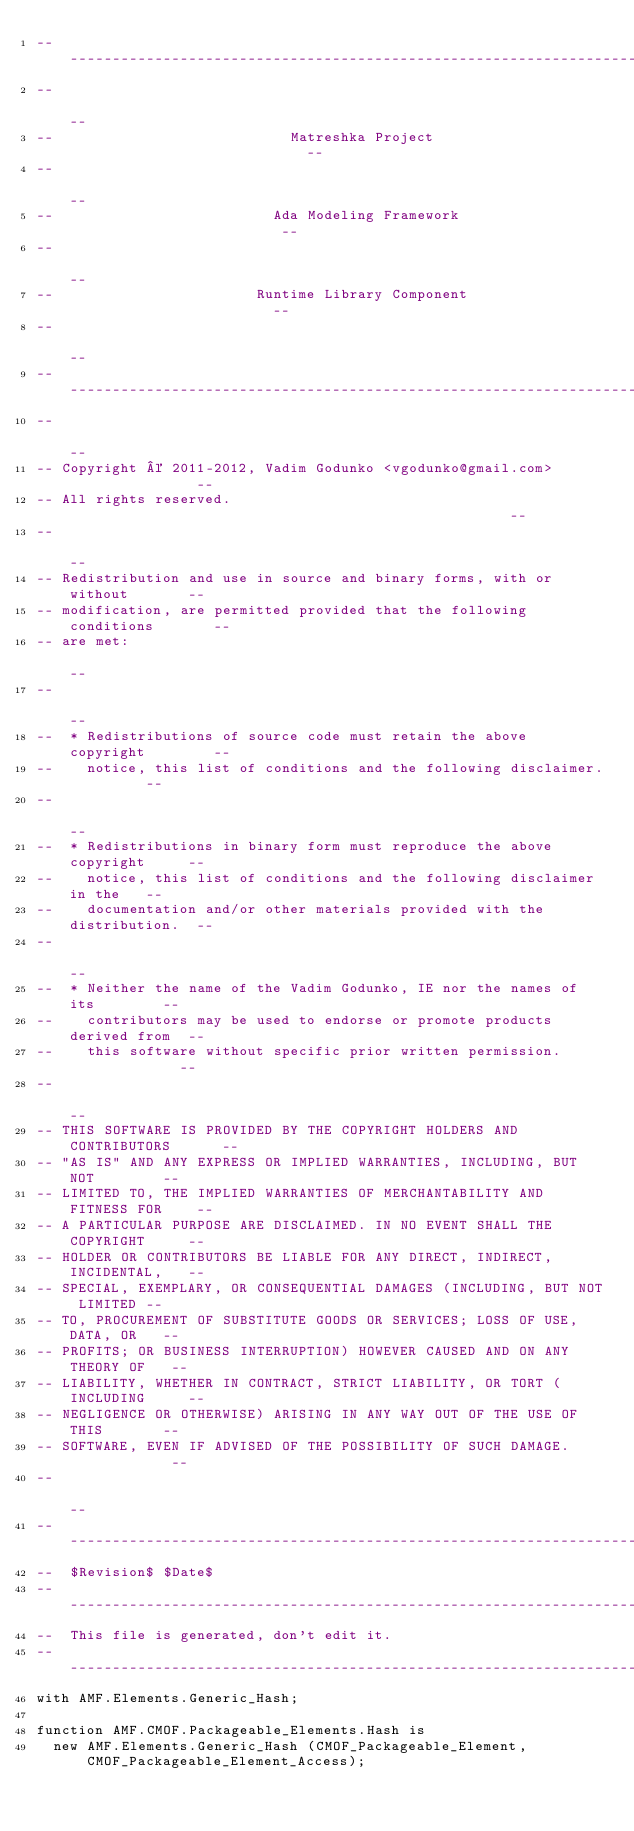<code> <loc_0><loc_0><loc_500><loc_500><_Ada_>------------------------------------------------------------------------------
--                                                                          --
--                            Matreshka Project                             --
--                                                                          --
--                          Ada Modeling Framework                          --
--                                                                          --
--                        Runtime Library Component                         --
--                                                                          --
------------------------------------------------------------------------------
--                                                                          --
-- Copyright © 2011-2012, Vadim Godunko <vgodunko@gmail.com>                --
-- All rights reserved.                                                     --
--                                                                          --
-- Redistribution and use in source and binary forms, with or without       --
-- modification, are permitted provided that the following conditions       --
-- are met:                                                                 --
--                                                                          --
--  * Redistributions of source code must retain the above copyright        --
--    notice, this list of conditions and the following disclaimer.         --
--                                                                          --
--  * Redistributions in binary form must reproduce the above copyright     --
--    notice, this list of conditions and the following disclaimer in the   --
--    documentation and/or other materials provided with the distribution.  --
--                                                                          --
--  * Neither the name of the Vadim Godunko, IE nor the names of its        --
--    contributors may be used to endorse or promote products derived from  --
--    this software without specific prior written permission.              --
--                                                                          --
-- THIS SOFTWARE IS PROVIDED BY THE COPYRIGHT HOLDERS AND CONTRIBUTORS      --
-- "AS IS" AND ANY EXPRESS OR IMPLIED WARRANTIES, INCLUDING, BUT NOT        --
-- LIMITED TO, THE IMPLIED WARRANTIES OF MERCHANTABILITY AND FITNESS FOR    --
-- A PARTICULAR PURPOSE ARE DISCLAIMED. IN NO EVENT SHALL THE COPYRIGHT     --
-- HOLDER OR CONTRIBUTORS BE LIABLE FOR ANY DIRECT, INDIRECT, INCIDENTAL,   --
-- SPECIAL, EXEMPLARY, OR CONSEQUENTIAL DAMAGES (INCLUDING, BUT NOT LIMITED --
-- TO, PROCUREMENT OF SUBSTITUTE GOODS OR SERVICES; LOSS OF USE, DATA, OR   --
-- PROFITS; OR BUSINESS INTERRUPTION) HOWEVER CAUSED AND ON ANY THEORY OF   --
-- LIABILITY, WHETHER IN CONTRACT, STRICT LIABILITY, OR TORT (INCLUDING     --
-- NEGLIGENCE OR OTHERWISE) ARISING IN ANY WAY OUT OF THE USE OF THIS       --
-- SOFTWARE, EVEN IF ADVISED OF THE POSSIBILITY OF SUCH DAMAGE.             --
--                                                                          --
------------------------------------------------------------------------------
--  $Revision$ $Date$
------------------------------------------------------------------------------
--  This file is generated, don't edit it.
------------------------------------------------------------------------------
with AMF.Elements.Generic_Hash;

function AMF.CMOF.Packageable_Elements.Hash is
  new AMF.Elements.Generic_Hash (CMOF_Packageable_Element, CMOF_Packageable_Element_Access);
</code> 